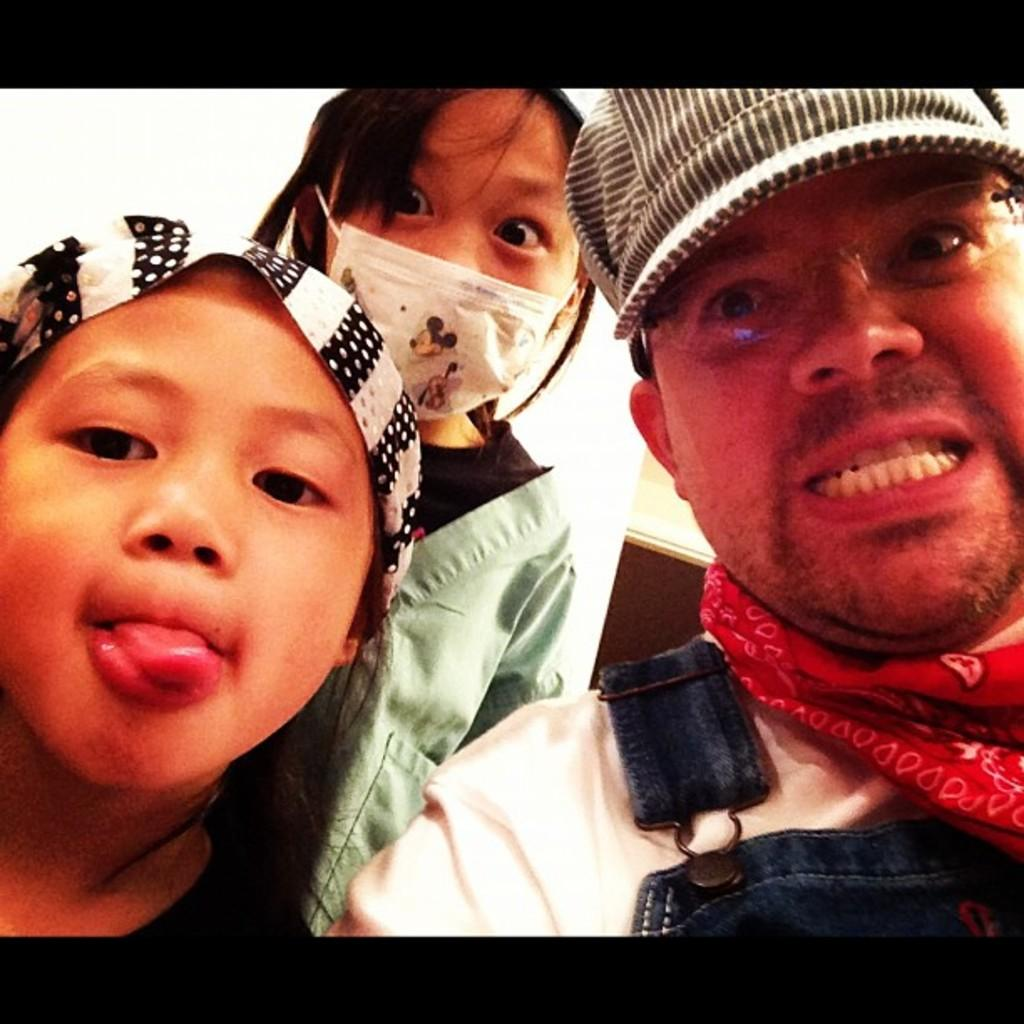What is the person in the image wearing? The person in the image is wearing a white and blue colored dress. How many other persons are there in the image, and what are they wearing? There are two other persons in the image, and they are wearing black and white colored dresses. What is the color of the background in the image? The background of the image is white. What is the person's tendency to fear tubs in the image? There is no mention of tubs or fear in the image, so it cannot be determined from the image. 